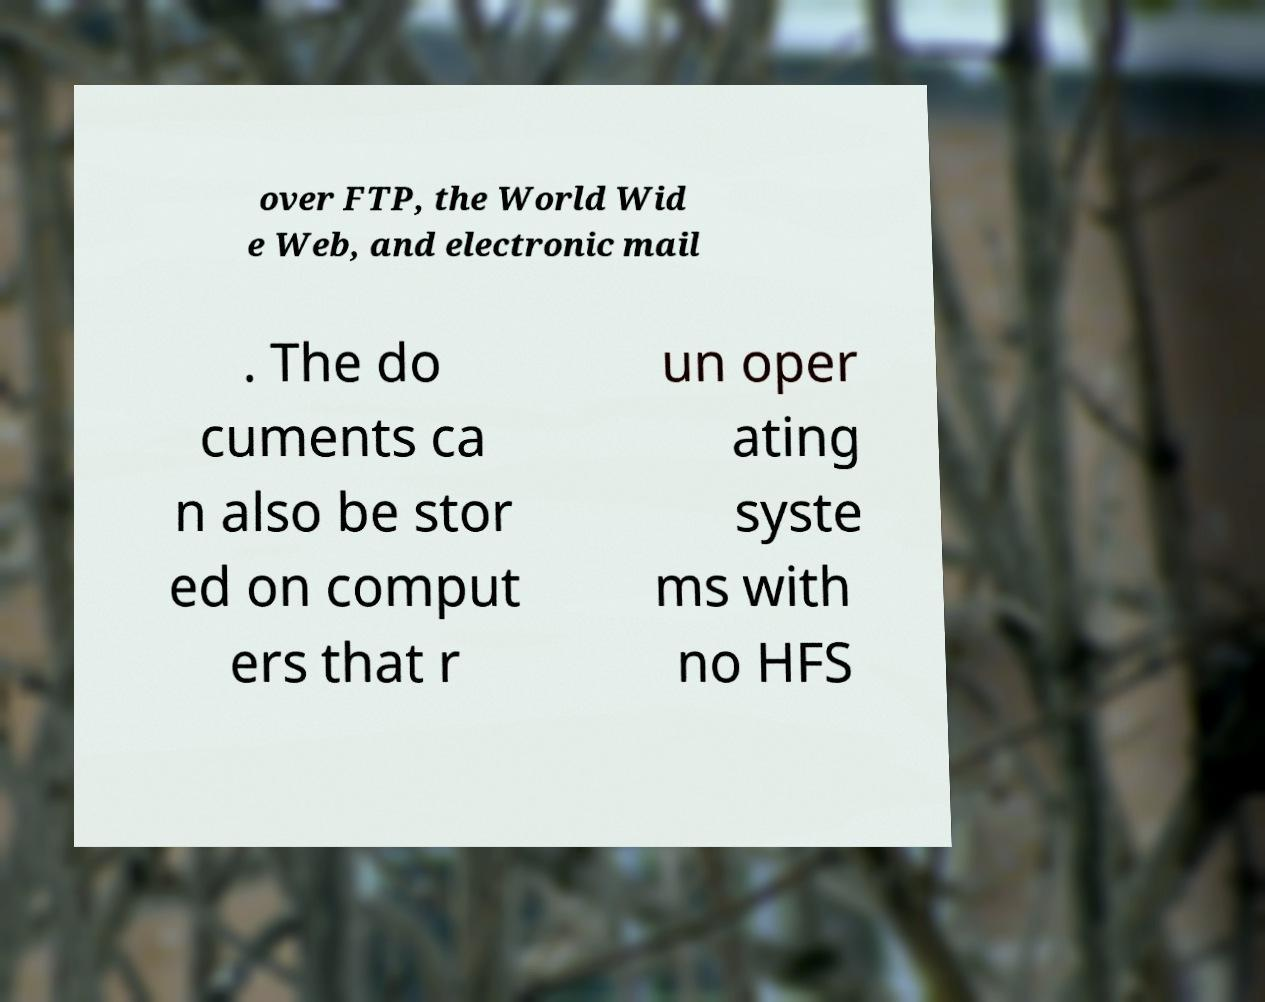What messages or text are displayed in this image? I need them in a readable, typed format. over FTP, the World Wid e Web, and electronic mail . The do cuments ca n also be stor ed on comput ers that r un oper ating syste ms with no HFS 